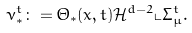Convert formula to latex. <formula><loc_0><loc_0><loc_500><loc_500>\nu _ { * } ^ { t } \colon = \Theta _ { * } ( x , t ) \mathcal { H } ^ { d - 2 } \llcorner \Sigma _ { \mu } ^ { t } .</formula> 